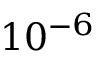Convert formula to latex. <formula><loc_0><loc_0><loc_500><loc_500>1 0 ^ { - 6 }</formula> 